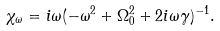Convert formula to latex. <formula><loc_0><loc_0><loc_500><loc_500>\chi _ { \omega } = i \omega ( - \omega ^ { 2 } + \Omega _ { 0 } ^ { 2 } + 2 i \omega \gamma ) ^ { - 1 } .</formula> 